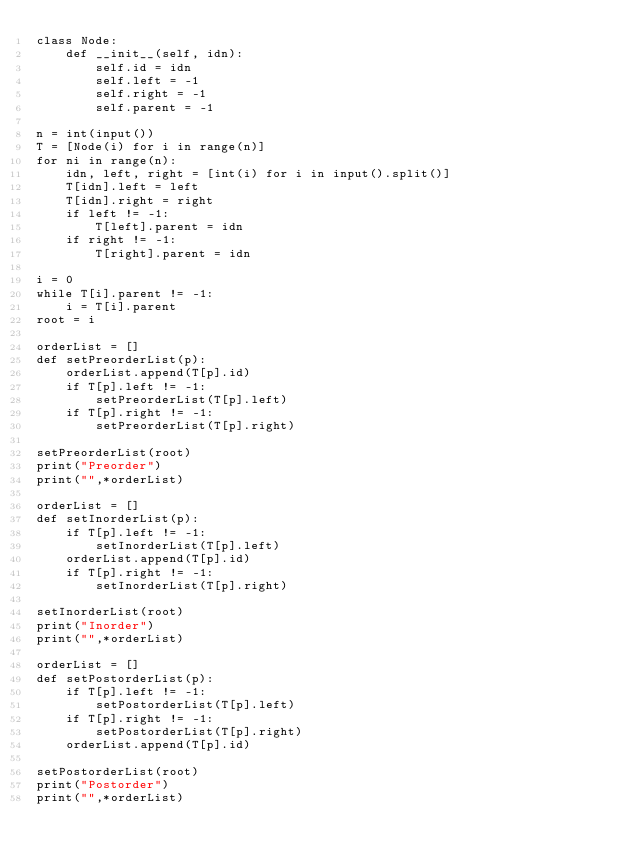<code> <loc_0><loc_0><loc_500><loc_500><_Python_>class Node:
    def __init__(self, idn):
        self.id = idn
        self.left = -1
        self.right = -1
        self.parent = -1

n = int(input())
T = [Node(i) for i in range(n)]
for ni in range(n):
    idn, left, right = [int(i) for i in input().split()]
    T[idn].left = left
    T[idn].right = right
    if left != -1:
        T[left].parent = idn
    if right != -1:
        T[right].parent = idn

i = 0
while T[i].parent != -1:
    i = T[i].parent
root = i

orderList = []
def setPreorderList(p):
    orderList.append(T[p].id)
    if T[p].left != -1:
        setPreorderList(T[p].left)
    if T[p].right != -1:
        setPreorderList(T[p].right)

setPreorderList(root)
print("Preorder")
print("",*orderList)

orderList = []
def setInorderList(p):
    if T[p].left != -1:
        setInorderList(T[p].left)
    orderList.append(T[p].id)
    if T[p].right != -1:
        setInorderList(T[p].right)

setInorderList(root)
print("Inorder")
print("",*orderList)

orderList = []
def setPostorderList(p):
    if T[p].left != -1:
        setPostorderList(T[p].left)
    if T[p].right != -1:
        setPostorderList(T[p].right)
    orderList.append(T[p].id)

setPostorderList(root)
print("Postorder")
print("",*orderList)
    
</code> 